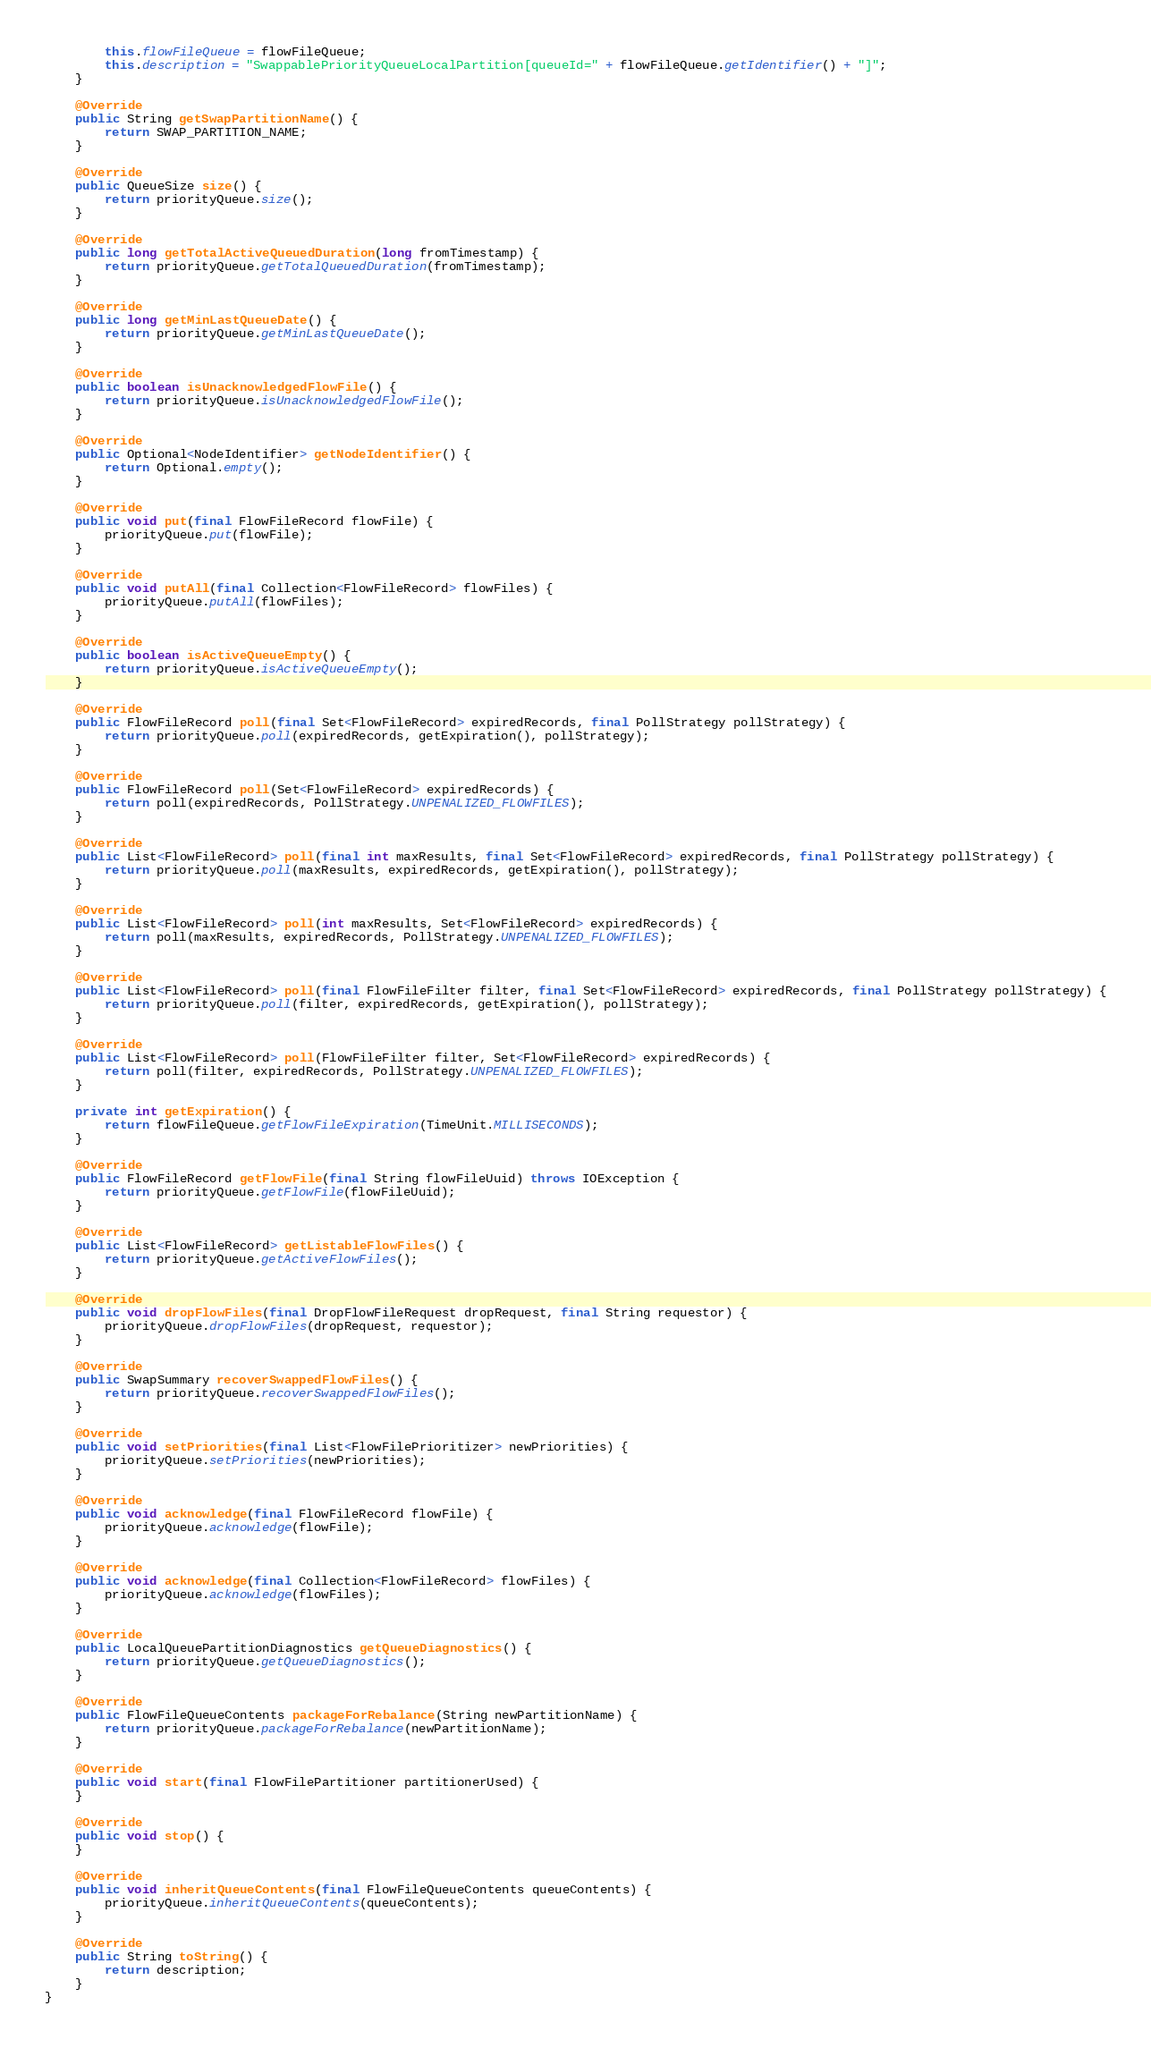Convert code to text. <code><loc_0><loc_0><loc_500><loc_500><_Java_>        this.flowFileQueue = flowFileQueue;
        this.description = "SwappablePriorityQueueLocalPartition[queueId=" + flowFileQueue.getIdentifier() + "]";
    }

    @Override
    public String getSwapPartitionName() {
        return SWAP_PARTITION_NAME;
    }

    @Override
    public QueueSize size() {
        return priorityQueue.size();
    }

    @Override
    public long getTotalActiveQueuedDuration(long fromTimestamp) {
        return priorityQueue.getTotalQueuedDuration(fromTimestamp);
    }

    @Override
    public long getMinLastQueueDate() {
        return priorityQueue.getMinLastQueueDate();
    }

    @Override
    public boolean isUnacknowledgedFlowFile() {
        return priorityQueue.isUnacknowledgedFlowFile();
    }

    @Override
    public Optional<NodeIdentifier> getNodeIdentifier() {
        return Optional.empty();
    }

    @Override
    public void put(final FlowFileRecord flowFile) {
        priorityQueue.put(flowFile);
    }

    @Override
    public void putAll(final Collection<FlowFileRecord> flowFiles) {
        priorityQueue.putAll(flowFiles);
    }

    @Override
    public boolean isActiveQueueEmpty() {
        return priorityQueue.isActiveQueueEmpty();
    }

    @Override
    public FlowFileRecord poll(final Set<FlowFileRecord> expiredRecords, final PollStrategy pollStrategy) {
        return priorityQueue.poll(expiredRecords, getExpiration(), pollStrategy);
    }

    @Override
    public FlowFileRecord poll(Set<FlowFileRecord> expiredRecords) {
        return poll(expiredRecords, PollStrategy.UNPENALIZED_FLOWFILES);
    }

    @Override
    public List<FlowFileRecord> poll(final int maxResults, final Set<FlowFileRecord> expiredRecords, final PollStrategy pollStrategy) {
        return priorityQueue.poll(maxResults, expiredRecords, getExpiration(), pollStrategy);
    }

    @Override
    public List<FlowFileRecord> poll(int maxResults, Set<FlowFileRecord> expiredRecords) {
        return poll(maxResults, expiredRecords, PollStrategy.UNPENALIZED_FLOWFILES);
    }

    @Override
    public List<FlowFileRecord> poll(final FlowFileFilter filter, final Set<FlowFileRecord> expiredRecords, final PollStrategy pollStrategy) {
        return priorityQueue.poll(filter, expiredRecords, getExpiration(), pollStrategy);
    }

    @Override
    public List<FlowFileRecord> poll(FlowFileFilter filter, Set<FlowFileRecord> expiredRecords) {
        return poll(filter, expiredRecords, PollStrategy.UNPENALIZED_FLOWFILES);
    }

    private int getExpiration() {
        return flowFileQueue.getFlowFileExpiration(TimeUnit.MILLISECONDS);
    }

    @Override
    public FlowFileRecord getFlowFile(final String flowFileUuid) throws IOException {
        return priorityQueue.getFlowFile(flowFileUuid);
    }

    @Override
    public List<FlowFileRecord> getListableFlowFiles() {
        return priorityQueue.getActiveFlowFiles();
    }

    @Override
    public void dropFlowFiles(final DropFlowFileRequest dropRequest, final String requestor) {
        priorityQueue.dropFlowFiles(dropRequest, requestor);
    }

    @Override
    public SwapSummary recoverSwappedFlowFiles() {
        return priorityQueue.recoverSwappedFlowFiles();
    }

    @Override
    public void setPriorities(final List<FlowFilePrioritizer> newPriorities) {
        priorityQueue.setPriorities(newPriorities);
    }

    @Override
    public void acknowledge(final FlowFileRecord flowFile) {
        priorityQueue.acknowledge(flowFile);
    }

    @Override
    public void acknowledge(final Collection<FlowFileRecord> flowFiles) {
        priorityQueue.acknowledge(flowFiles);
    }

    @Override
    public LocalQueuePartitionDiagnostics getQueueDiagnostics() {
        return priorityQueue.getQueueDiagnostics();
    }

    @Override
    public FlowFileQueueContents packageForRebalance(String newPartitionName) {
        return priorityQueue.packageForRebalance(newPartitionName);
    }

    @Override
    public void start(final FlowFilePartitioner partitionerUsed) {
    }

    @Override
    public void stop() {
    }

    @Override
    public void inheritQueueContents(final FlowFileQueueContents queueContents) {
        priorityQueue.inheritQueueContents(queueContents);
    }

    @Override
    public String toString() {
        return description;
    }
}
</code> 